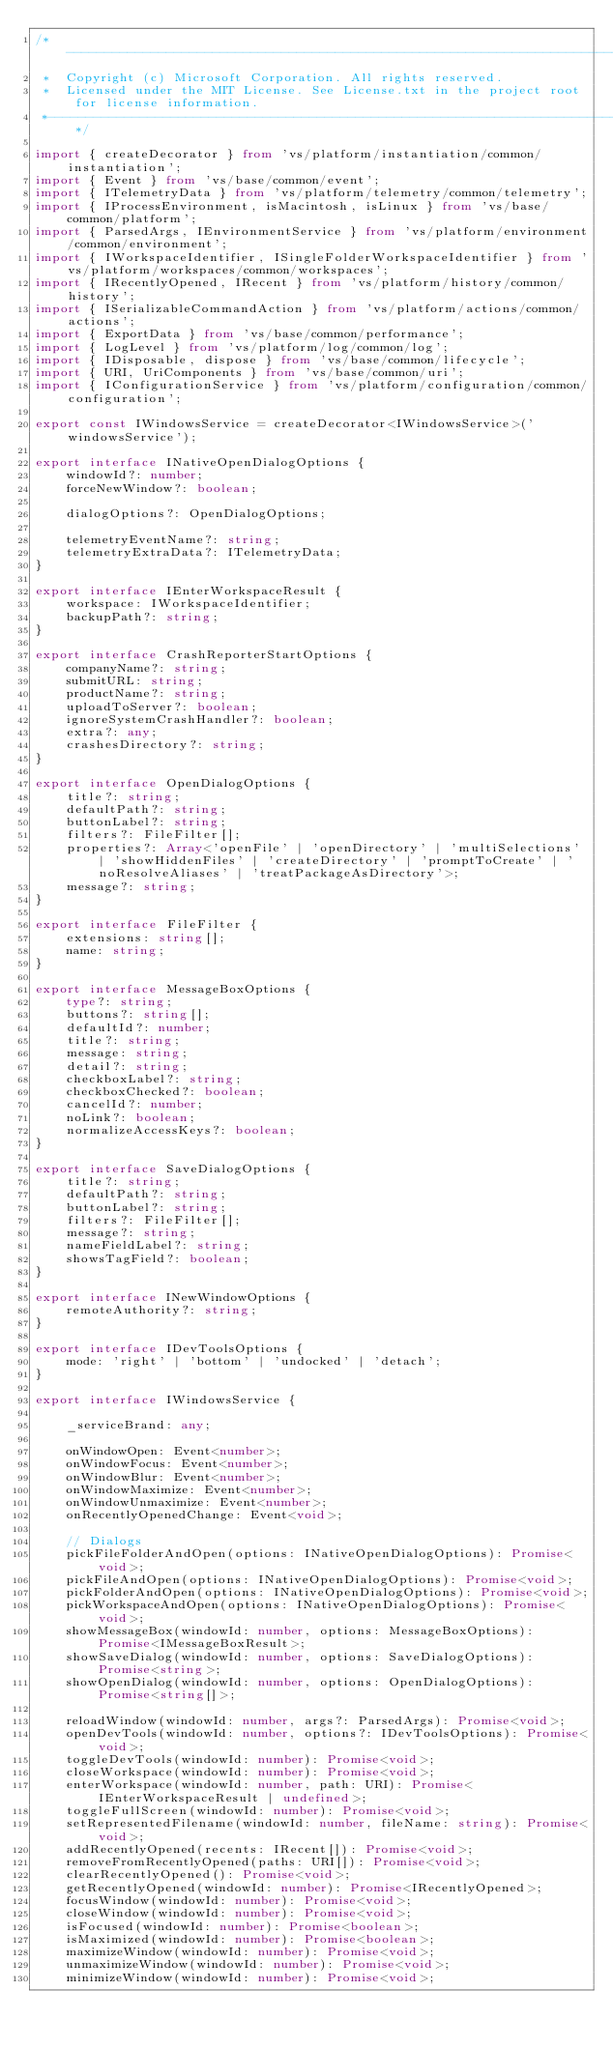<code> <loc_0><loc_0><loc_500><loc_500><_TypeScript_>/*---------------------------------------------------------------------------------------------
 *  Copyright (c) Microsoft Corporation. All rights reserved.
 *  Licensed under the MIT License. See License.txt in the project root for license information.
 *--------------------------------------------------------------------------------------------*/

import { createDecorator } from 'vs/platform/instantiation/common/instantiation';
import { Event } from 'vs/base/common/event';
import { ITelemetryData } from 'vs/platform/telemetry/common/telemetry';
import { IProcessEnvironment, isMacintosh, isLinux } from 'vs/base/common/platform';
import { ParsedArgs, IEnvironmentService } from 'vs/platform/environment/common/environment';
import { IWorkspaceIdentifier, ISingleFolderWorkspaceIdentifier } from 'vs/platform/workspaces/common/workspaces';
import { IRecentlyOpened, IRecent } from 'vs/platform/history/common/history';
import { ISerializableCommandAction } from 'vs/platform/actions/common/actions';
import { ExportData } from 'vs/base/common/performance';
import { LogLevel } from 'vs/platform/log/common/log';
import { IDisposable, dispose } from 'vs/base/common/lifecycle';
import { URI, UriComponents } from 'vs/base/common/uri';
import { IConfigurationService } from 'vs/platform/configuration/common/configuration';

export const IWindowsService = createDecorator<IWindowsService>('windowsService');

export interface INativeOpenDialogOptions {
	windowId?: number;
	forceNewWindow?: boolean;

	dialogOptions?: OpenDialogOptions;

	telemetryEventName?: string;
	telemetryExtraData?: ITelemetryData;
}

export interface IEnterWorkspaceResult {
	workspace: IWorkspaceIdentifier;
	backupPath?: string;
}

export interface CrashReporterStartOptions {
	companyName?: string;
	submitURL: string;
	productName?: string;
	uploadToServer?: boolean;
	ignoreSystemCrashHandler?: boolean;
	extra?: any;
	crashesDirectory?: string;
}

export interface OpenDialogOptions {
	title?: string;
	defaultPath?: string;
	buttonLabel?: string;
	filters?: FileFilter[];
	properties?: Array<'openFile' | 'openDirectory' | 'multiSelections' | 'showHiddenFiles' | 'createDirectory' | 'promptToCreate' | 'noResolveAliases' | 'treatPackageAsDirectory'>;
	message?: string;
}

export interface FileFilter {
	extensions: string[];
	name: string;
}

export interface MessageBoxOptions {
	type?: string;
	buttons?: string[];
	defaultId?: number;
	title?: string;
	message: string;
	detail?: string;
	checkboxLabel?: string;
	checkboxChecked?: boolean;
	cancelId?: number;
	noLink?: boolean;
	normalizeAccessKeys?: boolean;
}

export interface SaveDialogOptions {
	title?: string;
	defaultPath?: string;
	buttonLabel?: string;
	filters?: FileFilter[];
	message?: string;
	nameFieldLabel?: string;
	showsTagField?: boolean;
}

export interface INewWindowOptions {
	remoteAuthority?: string;
}

export interface IDevToolsOptions {
	mode: 'right' | 'bottom' | 'undocked' | 'detach';
}

export interface IWindowsService {

	_serviceBrand: any;

	onWindowOpen: Event<number>;
	onWindowFocus: Event<number>;
	onWindowBlur: Event<number>;
	onWindowMaximize: Event<number>;
	onWindowUnmaximize: Event<number>;
	onRecentlyOpenedChange: Event<void>;

	// Dialogs
	pickFileFolderAndOpen(options: INativeOpenDialogOptions): Promise<void>;
	pickFileAndOpen(options: INativeOpenDialogOptions): Promise<void>;
	pickFolderAndOpen(options: INativeOpenDialogOptions): Promise<void>;
	pickWorkspaceAndOpen(options: INativeOpenDialogOptions): Promise<void>;
	showMessageBox(windowId: number, options: MessageBoxOptions): Promise<IMessageBoxResult>;
	showSaveDialog(windowId: number, options: SaveDialogOptions): Promise<string>;
	showOpenDialog(windowId: number, options: OpenDialogOptions): Promise<string[]>;

	reloadWindow(windowId: number, args?: ParsedArgs): Promise<void>;
	openDevTools(windowId: number, options?: IDevToolsOptions): Promise<void>;
	toggleDevTools(windowId: number): Promise<void>;
	closeWorkspace(windowId: number): Promise<void>;
	enterWorkspace(windowId: number, path: URI): Promise<IEnterWorkspaceResult | undefined>;
	toggleFullScreen(windowId: number): Promise<void>;
	setRepresentedFilename(windowId: number, fileName: string): Promise<void>;
	addRecentlyOpened(recents: IRecent[]): Promise<void>;
	removeFromRecentlyOpened(paths: URI[]): Promise<void>;
	clearRecentlyOpened(): Promise<void>;
	getRecentlyOpened(windowId: number): Promise<IRecentlyOpened>;
	focusWindow(windowId: number): Promise<void>;
	closeWindow(windowId: number): Promise<void>;
	isFocused(windowId: number): Promise<boolean>;
	isMaximized(windowId: number): Promise<boolean>;
	maximizeWindow(windowId: number): Promise<void>;
	unmaximizeWindow(windowId: number): Promise<void>;
	minimizeWindow(windowId: number): Promise<void>;</code> 